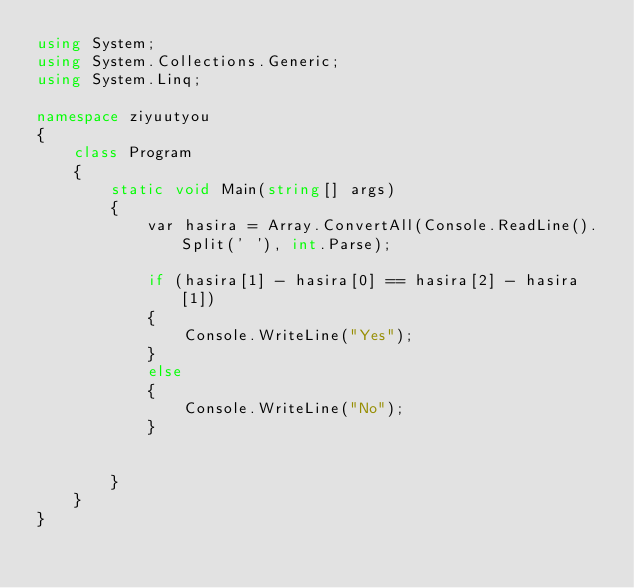<code> <loc_0><loc_0><loc_500><loc_500><_C#_>using System;
using System.Collections.Generic;
using System.Linq;

namespace ziyuutyou
{
    class Program
    {
        static void Main(string[] args)
        {
            var hasira = Array.ConvertAll(Console.ReadLine().Split(' '), int.Parse);

            if (hasira[1] - hasira[0] == hasira[2] - hasira[1])
            {
                Console.WriteLine("Yes");
            }
            else
            {
                Console.WriteLine("No");
            }
            
                
        }
    }
}
</code> 